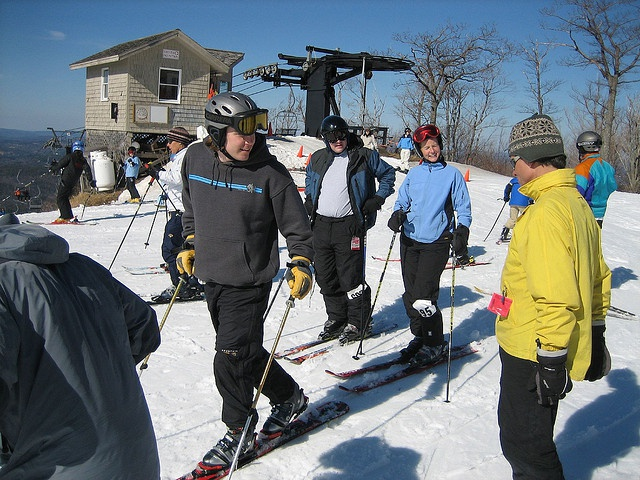Describe the objects in this image and their specific colors. I can see people in blue, black, gray, and darkblue tones, people in blue, black, gray, and darkgray tones, people in blue, gold, black, khaki, and tan tones, people in blue, black, lightgray, and gray tones, and people in blue, black, lightblue, and lightgray tones in this image. 